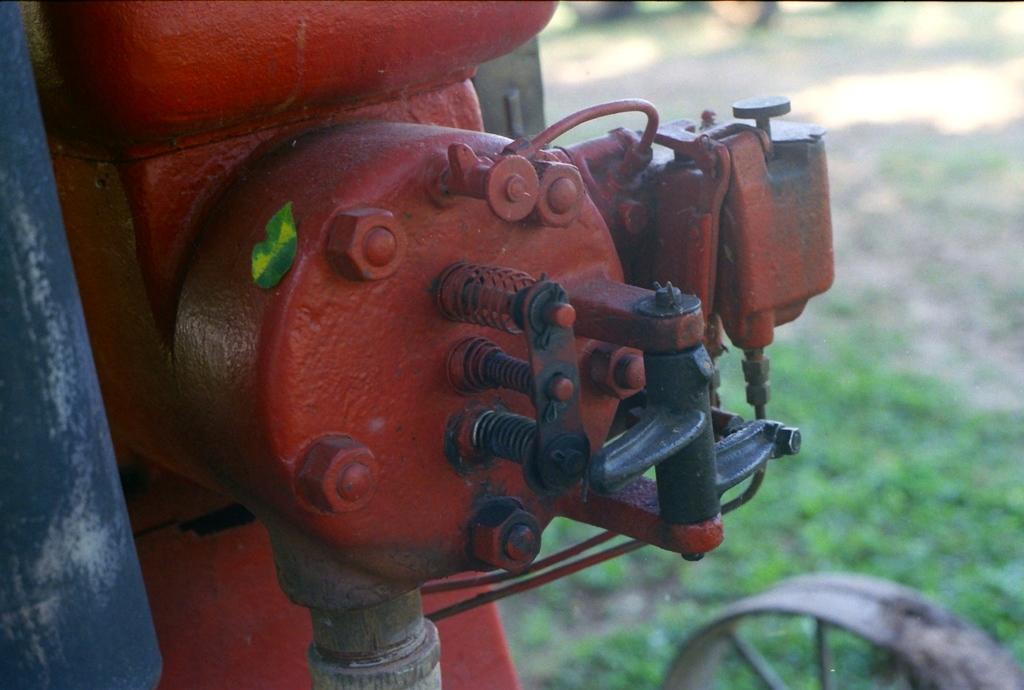What is the main object in the image? There is a motor in the image. Where is the motor located? The motor is on a grassland. What feature can be seen on the motor? There is a wheel on the front right side corner of the motor. What color is the nose of the motor in the image? There is no nose present on the motor in the image, as it is a mechanical object and not a living being. 